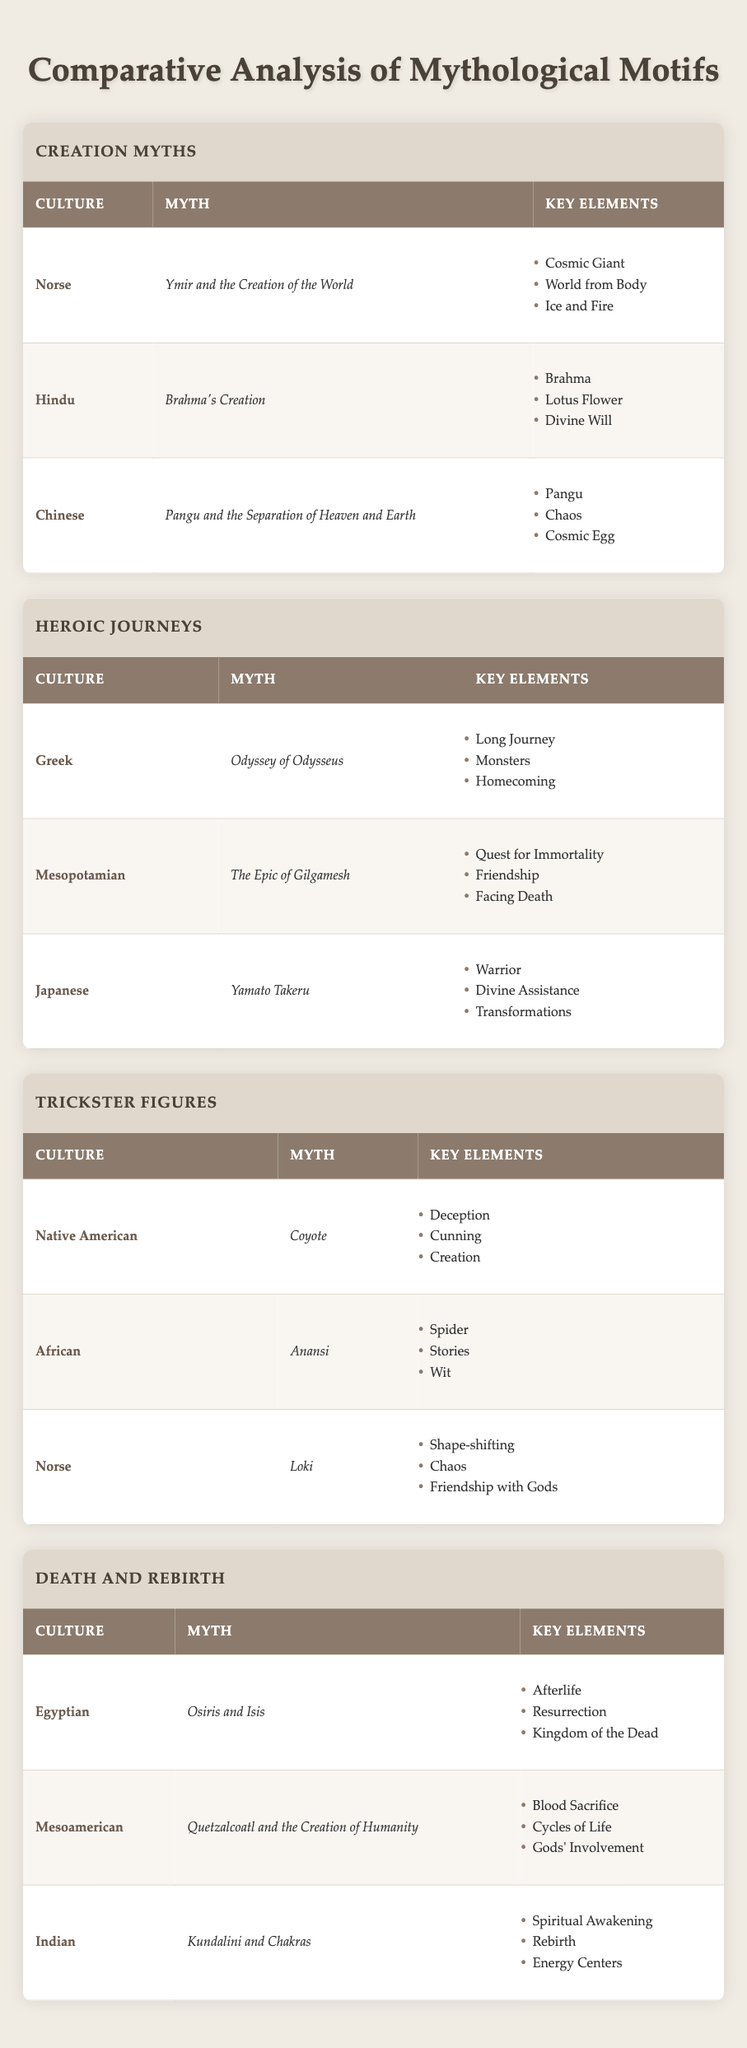What myths are associated with the Norse culture? The table indicates that the Norse culture is associated with the myth "Ymir and the Creation of the World" under the Creation Myths section and "Loki" under the Trickster Figures section.
Answer: Ymir and the Creation of the World; Loki Which myth involves a quest for immortality? In the Heroic Journeys section, the myth tied to a quest for immortality is "The Epic of Gilgamesh" from the Mesopotamian culture.
Answer: The Epic of Gilgamesh Is the Lotus Flower a key element in Hindu creation myths? The table shows that in Hindu creation myths, specifically in "Brahma's Creation," the Lotus Flower is listed among the key elements. Therefore, it is true.
Answer: Yes What are the key elements of the myth "Osiris and Isis"? Referring to the Death and Rebirth section, the key elements for "Osiris and Isis" are Afterlife, Resurrection, and Kingdom of the Dead.
Answer: Afterlife; Resurrection; Kingdom of the Dead How many cultures listed feature a trickster figure? There are three cultures listed under the Trickster Figures: Native American (Coyote), African (Anansi), and Norse (Loki). Therefore, there are three cultures that feature a trickster figure.
Answer: Three Which culture has a myth that includes cycles of life? In the Death and Rebirth section, the Mesoamerican culture's myth "Quetzalcoatl and the Creation of Humanity" includes the key element of cycles of life.
Answer: Mesoamerican Which two myths focus on divine assistance or divine will? The myth "Brahma's Creation" from the Hindu culture focuses on divine will, whereas "Yamato Takeru" from the Japanese culture involves divine assistance.
Answer: Brahma's Creation; Yamato Takeru What is the average number of key elements across all listed myths? The key elements are as follows: "Ymir and the Creation of the World" (3), "Brahma's Creation" (3), "Pangu and the Separation of Heaven and Earth" (3), "Odyssey of Odysseus" (3), "The Epic of Gilgamesh" (3), "Yamato Takeru" (3), "Coyote" (3), "Anansi" (3), "Loki" (3), "Osiris and Isis" (3), "Quetzalcoatl and the Creation of Humanity" (3), "Kundalini and Chakras" (3). There are 12 myths total with 3 key elements each, leading to an average of 3.
Answer: 3 